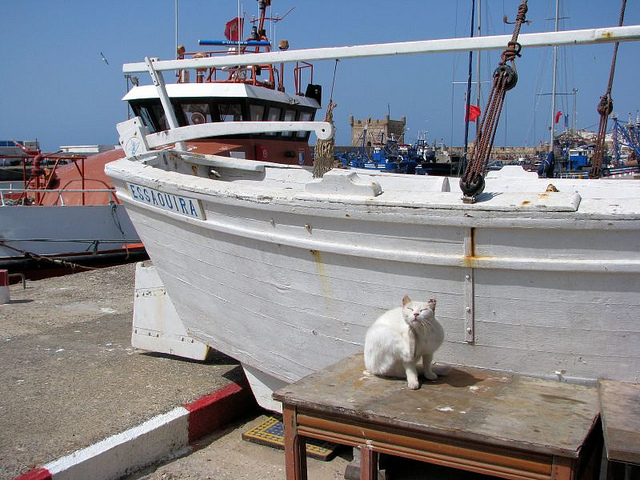<image>Is this cat going boating? I don't know if the cat is going boating. Is this cat going boating? I don't know if the cat is going boating. It doesn't seem like the cat is going boating based on the given answers. 